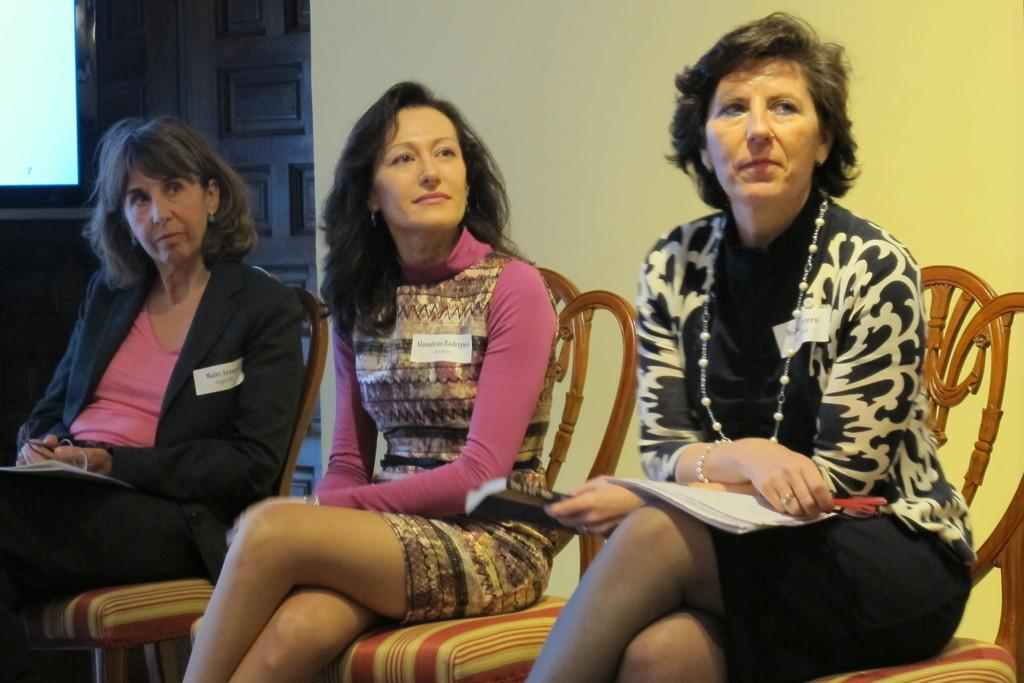How many women are present in the image? There are three women in the image. What are the women doing in the image? The women are sitting on chairs. Can you describe the activity of the woman on the right side? The woman on the right side is holding a book. What type of surprise can be seen on the earth in the image? There is no surprise or earth present in the image; it features three women sitting on chairs. Can you tell me what type of camera is being used to take the picture? There is no camera visible in the image, as it is a still photograph of the three women. 